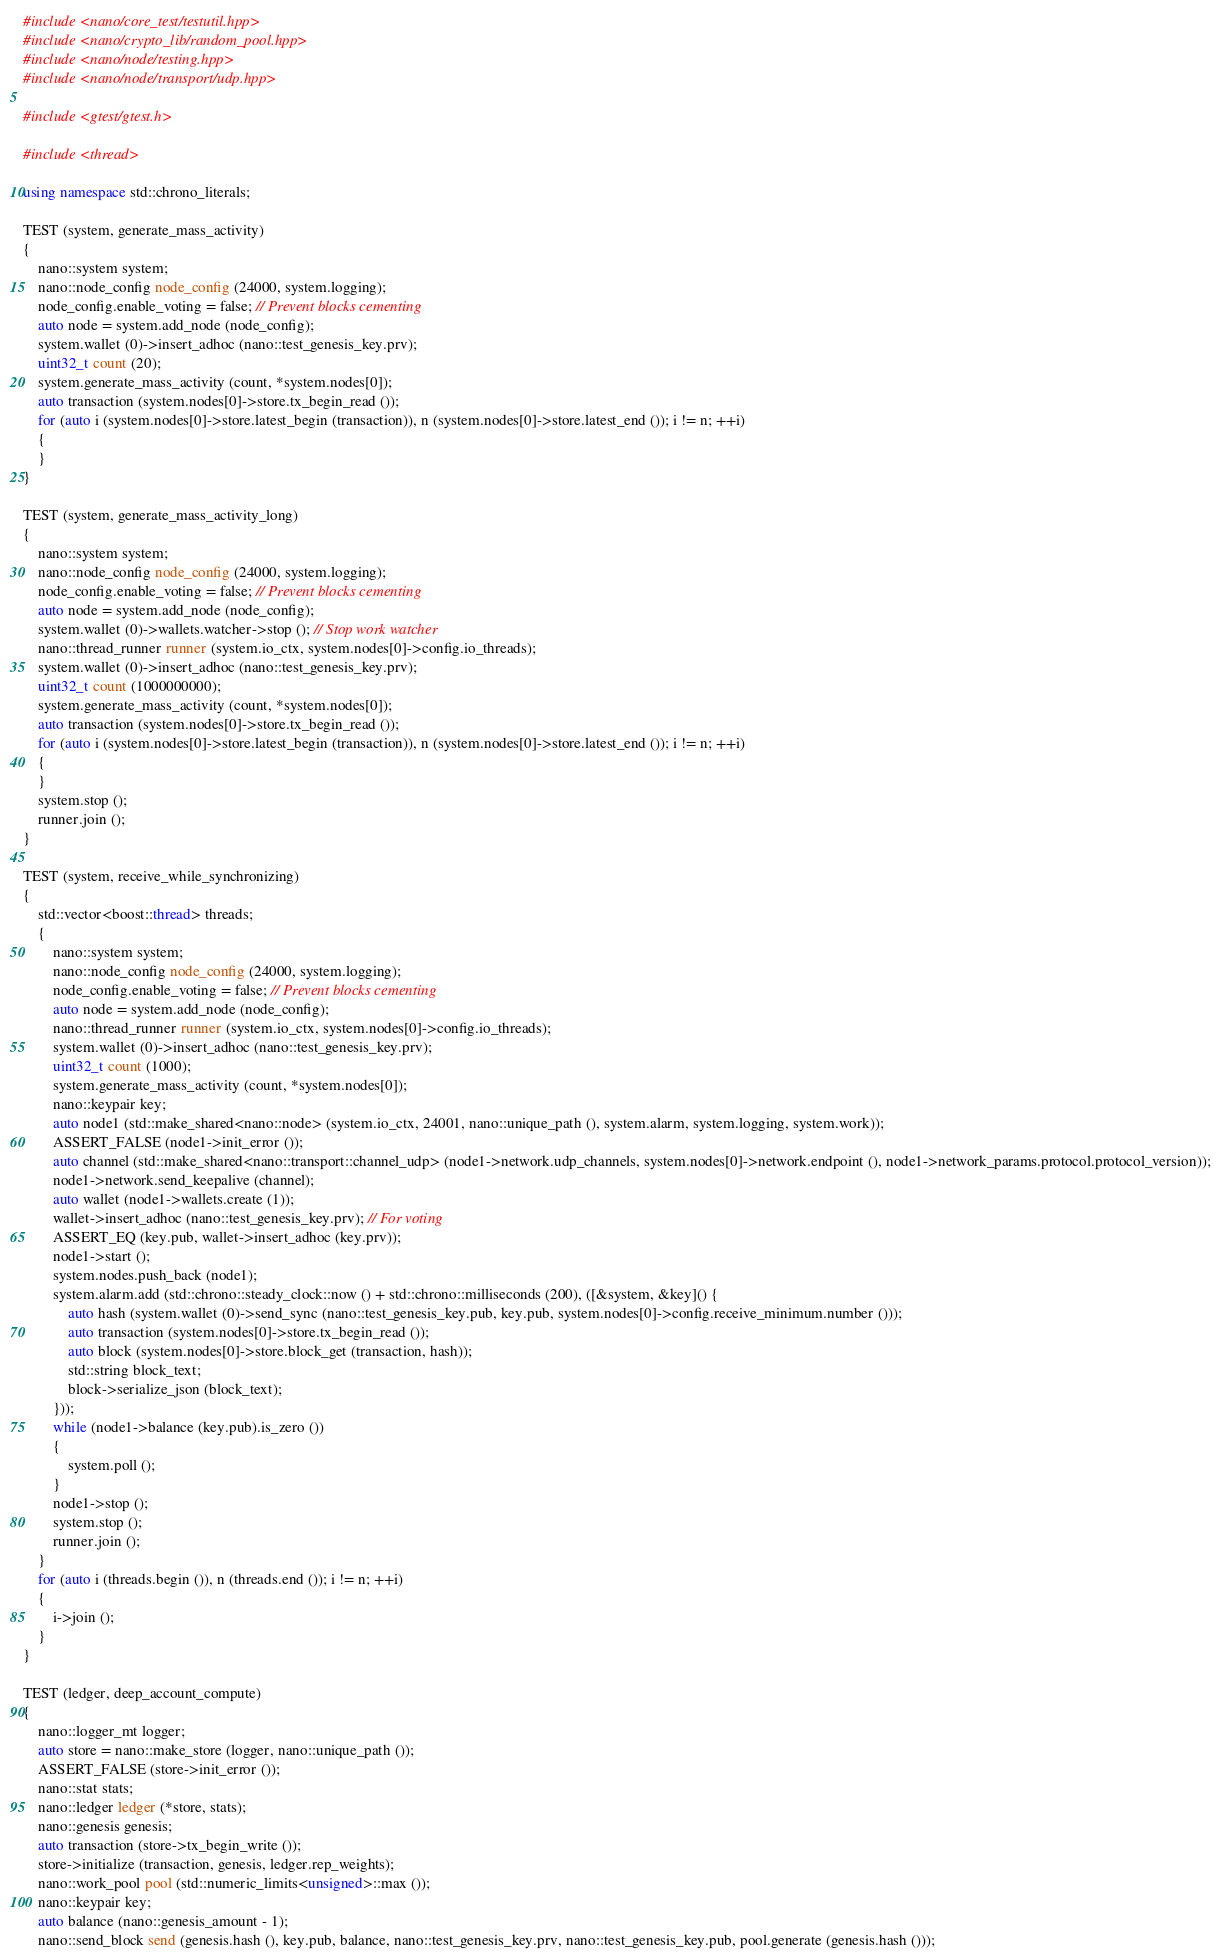Convert code to text. <code><loc_0><loc_0><loc_500><loc_500><_C++_>#include <nano/core_test/testutil.hpp>
#include <nano/crypto_lib/random_pool.hpp>
#include <nano/node/testing.hpp>
#include <nano/node/transport/udp.hpp>

#include <gtest/gtest.h>

#include <thread>

using namespace std::chrono_literals;

TEST (system, generate_mass_activity)
{
	nano::system system;
	nano::node_config node_config (24000, system.logging);
	node_config.enable_voting = false; // Prevent blocks cementing
	auto node = system.add_node (node_config);
	system.wallet (0)->insert_adhoc (nano::test_genesis_key.prv);
	uint32_t count (20);
	system.generate_mass_activity (count, *system.nodes[0]);
	auto transaction (system.nodes[0]->store.tx_begin_read ());
	for (auto i (system.nodes[0]->store.latest_begin (transaction)), n (system.nodes[0]->store.latest_end ()); i != n; ++i)
	{
	}
}

TEST (system, generate_mass_activity_long)
{
	nano::system system;
	nano::node_config node_config (24000, system.logging);
	node_config.enable_voting = false; // Prevent blocks cementing
	auto node = system.add_node (node_config);
	system.wallet (0)->wallets.watcher->stop (); // Stop work watcher
	nano::thread_runner runner (system.io_ctx, system.nodes[0]->config.io_threads);
	system.wallet (0)->insert_adhoc (nano::test_genesis_key.prv);
	uint32_t count (1000000000);
	system.generate_mass_activity (count, *system.nodes[0]);
	auto transaction (system.nodes[0]->store.tx_begin_read ());
	for (auto i (system.nodes[0]->store.latest_begin (transaction)), n (system.nodes[0]->store.latest_end ()); i != n; ++i)
	{
	}
	system.stop ();
	runner.join ();
}

TEST (system, receive_while_synchronizing)
{
	std::vector<boost::thread> threads;
	{
		nano::system system;
		nano::node_config node_config (24000, system.logging);
		node_config.enable_voting = false; // Prevent blocks cementing
		auto node = system.add_node (node_config);
		nano::thread_runner runner (system.io_ctx, system.nodes[0]->config.io_threads);
		system.wallet (0)->insert_adhoc (nano::test_genesis_key.prv);
		uint32_t count (1000);
		system.generate_mass_activity (count, *system.nodes[0]);
		nano::keypair key;
		auto node1 (std::make_shared<nano::node> (system.io_ctx, 24001, nano::unique_path (), system.alarm, system.logging, system.work));
		ASSERT_FALSE (node1->init_error ());
		auto channel (std::make_shared<nano::transport::channel_udp> (node1->network.udp_channels, system.nodes[0]->network.endpoint (), node1->network_params.protocol.protocol_version));
		node1->network.send_keepalive (channel);
		auto wallet (node1->wallets.create (1));
		wallet->insert_adhoc (nano::test_genesis_key.prv); // For voting
		ASSERT_EQ (key.pub, wallet->insert_adhoc (key.prv));
		node1->start ();
		system.nodes.push_back (node1);
		system.alarm.add (std::chrono::steady_clock::now () + std::chrono::milliseconds (200), ([&system, &key]() {
			auto hash (system.wallet (0)->send_sync (nano::test_genesis_key.pub, key.pub, system.nodes[0]->config.receive_minimum.number ()));
			auto transaction (system.nodes[0]->store.tx_begin_read ());
			auto block (system.nodes[0]->store.block_get (transaction, hash));
			std::string block_text;
			block->serialize_json (block_text);
		}));
		while (node1->balance (key.pub).is_zero ())
		{
			system.poll ();
		}
		node1->stop ();
		system.stop ();
		runner.join ();
	}
	for (auto i (threads.begin ()), n (threads.end ()); i != n; ++i)
	{
		i->join ();
	}
}

TEST (ledger, deep_account_compute)
{
	nano::logger_mt logger;
	auto store = nano::make_store (logger, nano::unique_path ());
	ASSERT_FALSE (store->init_error ());
	nano::stat stats;
	nano::ledger ledger (*store, stats);
	nano::genesis genesis;
	auto transaction (store->tx_begin_write ());
	store->initialize (transaction, genesis, ledger.rep_weights);
	nano::work_pool pool (std::numeric_limits<unsigned>::max ());
	nano::keypair key;
	auto balance (nano::genesis_amount - 1);
	nano::send_block send (genesis.hash (), key.pub, balance, nano::test_genesis_key.prv, nano::test_genesis_key.pub, pool.generate (genesis.hash ()));</code> 